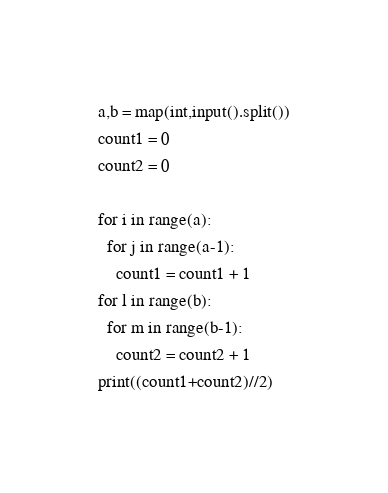<code> <loc_0><loc_0><loc_500><loc_500><_Python_>a,b = map(int,input().split())
count1 = 0
count2 = 0

for i in range(a):
  for j in range(a-1):
    count1 = count1 + 1
for l in range(b):
  for m in range(b-1):
    count2 = count2 + 1
print((count1+count2)//2)</code> 